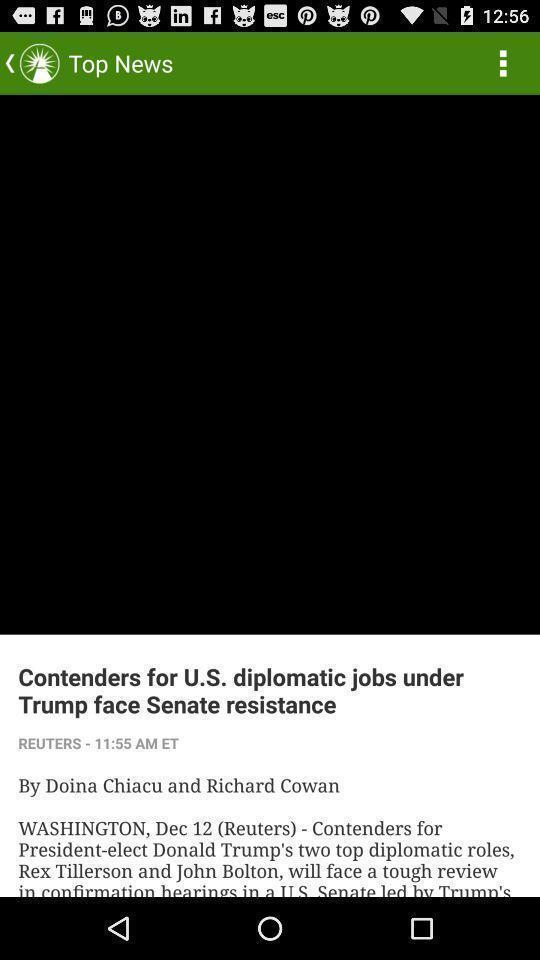Tell me about the visual elements in this screen capture. Screen shows top news in a news app. 